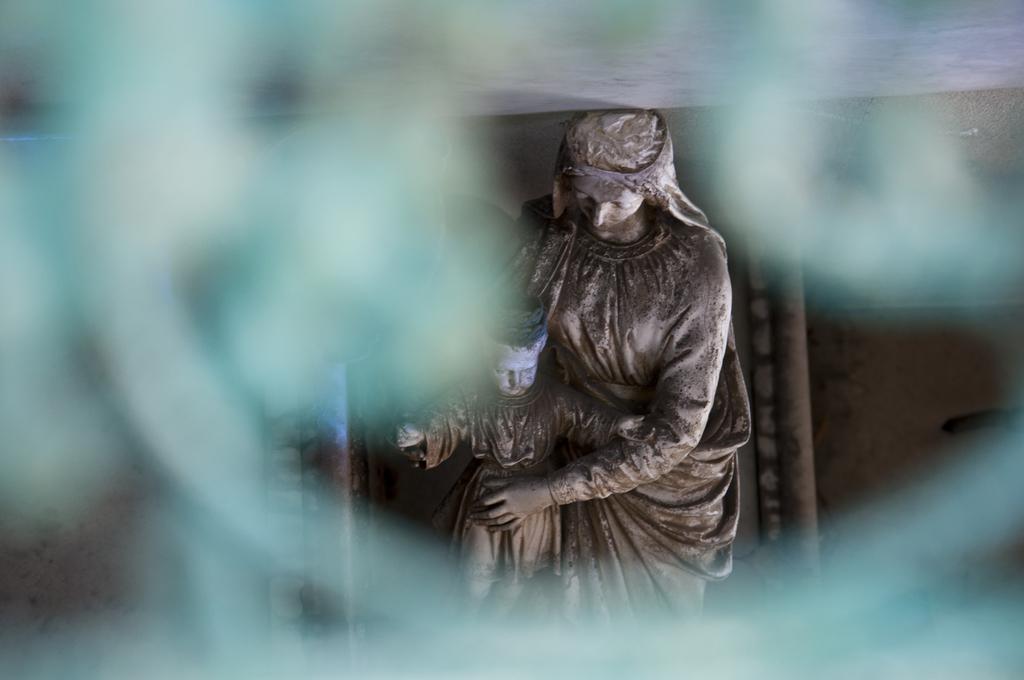Can you describe this image briefly? Here we can see sculptures. Surrounding it is blurry. 